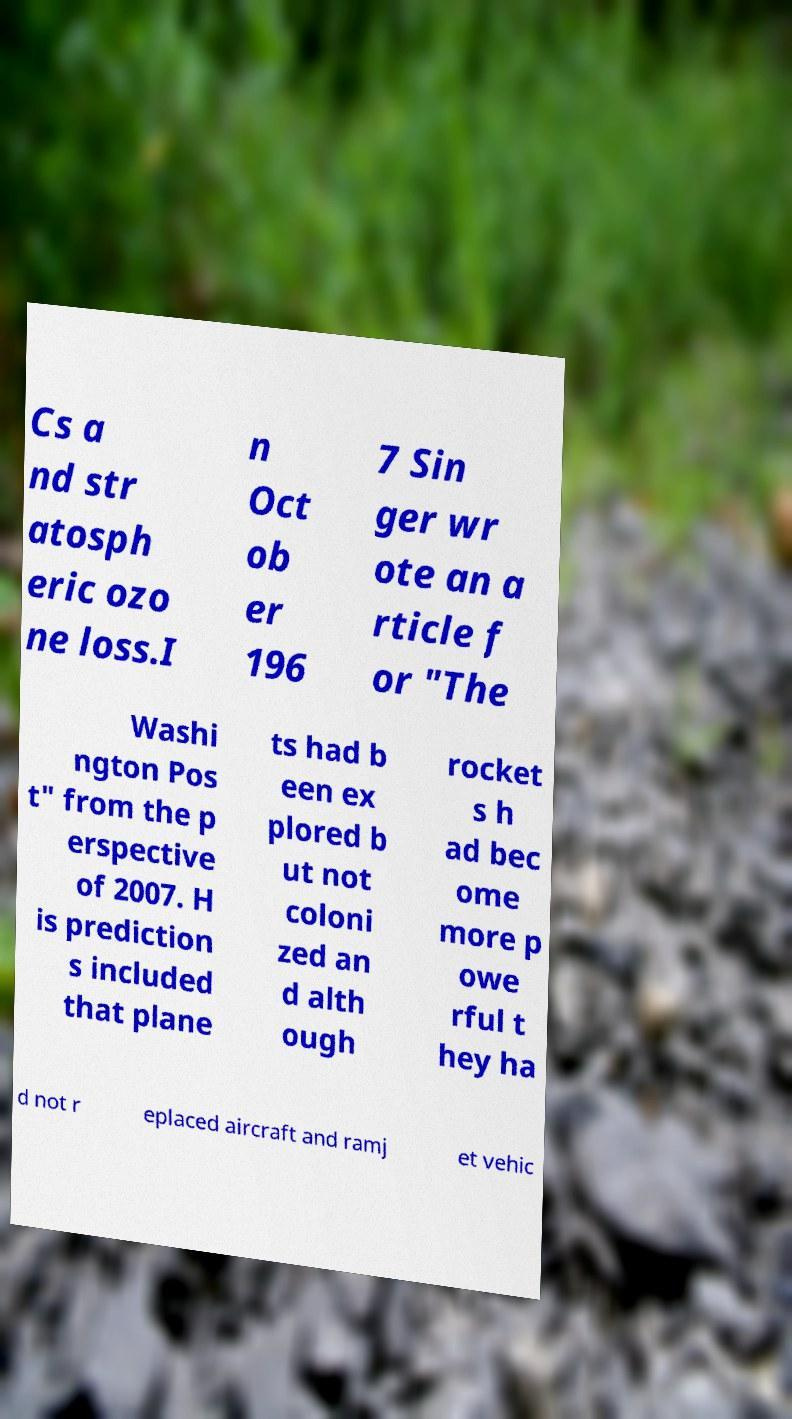Please identify and transcribe the text found in this image. Cs a nd str atosph eric ozo ne loss.I n Oct ob er 196 7 Sin ger wr ote an a rticle f or "The Washi ngton Pos t" from the p erspective of 2007. H is prediction s included that plane ts had b een ex plored b ut not coloni zed an d alth ough rocket s h ad bec ome more p owe rful t hey ha d not r eplaced aircraft and ramj et vehic 